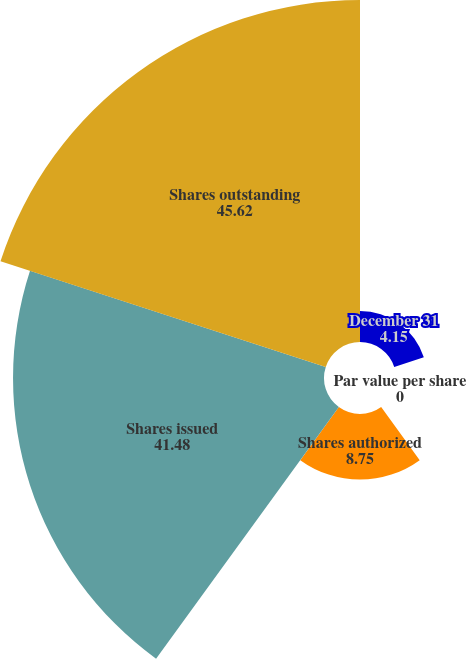Convert chart to OTSL. <chart><loc_0><loc_0><loc_500><loc_500><pie_chart><fcel>December 31<fcel>Par value per share<fcel>Shares authorized<fcel>Shares issued<fcel>Shares outstanding<nl><fcel>4.15%<fcel>0.0%<fcel>8.75%<fcel>41.48%<fcel>45.62%<nl></chart> 